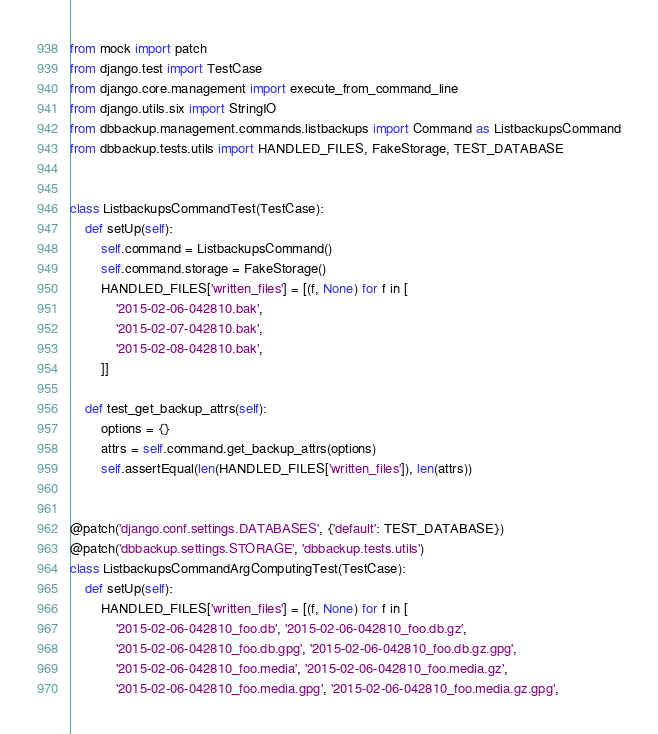<code> <loc_0><loc_0><loc_500><loc_500><_Python_>from mock import patch
from django.test import TestCase
from django.core.management import execute_from_command_line
from django.utils.six import StringIO
from dbbackup.management.commands.listbackups import Command as ListbackupsCommand
from dbbackup.tests.utils import HANDLED_FILES, FakeStorage, TEST_DATABASE


class ListbackupsCommandTest(TestCase):
    def setUp(self):
        self.command = ListbackupsCommand()
        self.command.storage = FakeStorage()
        HANDLED_FILES['written_files'] = [(f, None) for f in [
            '2015-02-06-042810.bak',
            '2015-02-07-042810.bak',
            '2015-02-08-042810.bak',
        ]]

    def test_get_backup_attrs(self):
        options = {}
        attrs = self.command.get_backup_attrs(options)
        self.assertEqual(len(HANDLED_FILES['written_files']), len(attrs))


@patch('django.conf.settings.DATABASES', {'default': TEST_DATABASE})
@patch('dbbackup.settings.STORAGE', 'dbbackup.tests.utils')
class ListbackupsCommandArgComputingTest(TestCase):
    def setUp(self):
        HANDLED_FILES['written_files'] = [(f, None) for f in [
            '2015-02-06-042810_foo.db', '2015-02-06-042810_foo.db.gz',
            '2015-02-06-042810_foo.db.gpg', '2015-02-06-042810_foo.db.gz.gpg',
            '2015-02-06-042810_foo.media', '2015-02-06-042810_foo.media.gz',
            '2015-02-06-042810_foo.media.gpg', '2015-02-06-042810_foo.media.gz.gpg',</code> 